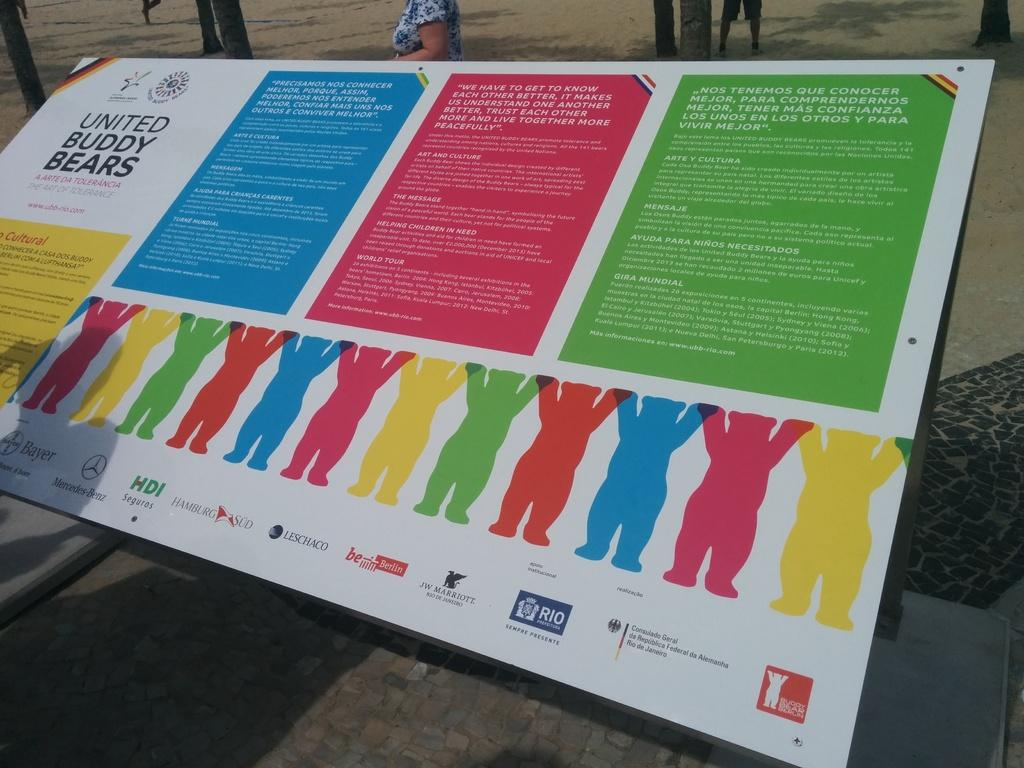<image>
Relay a brief, clear account of the picture shown. "United Buddy Bears" is listed on this informative advert. 